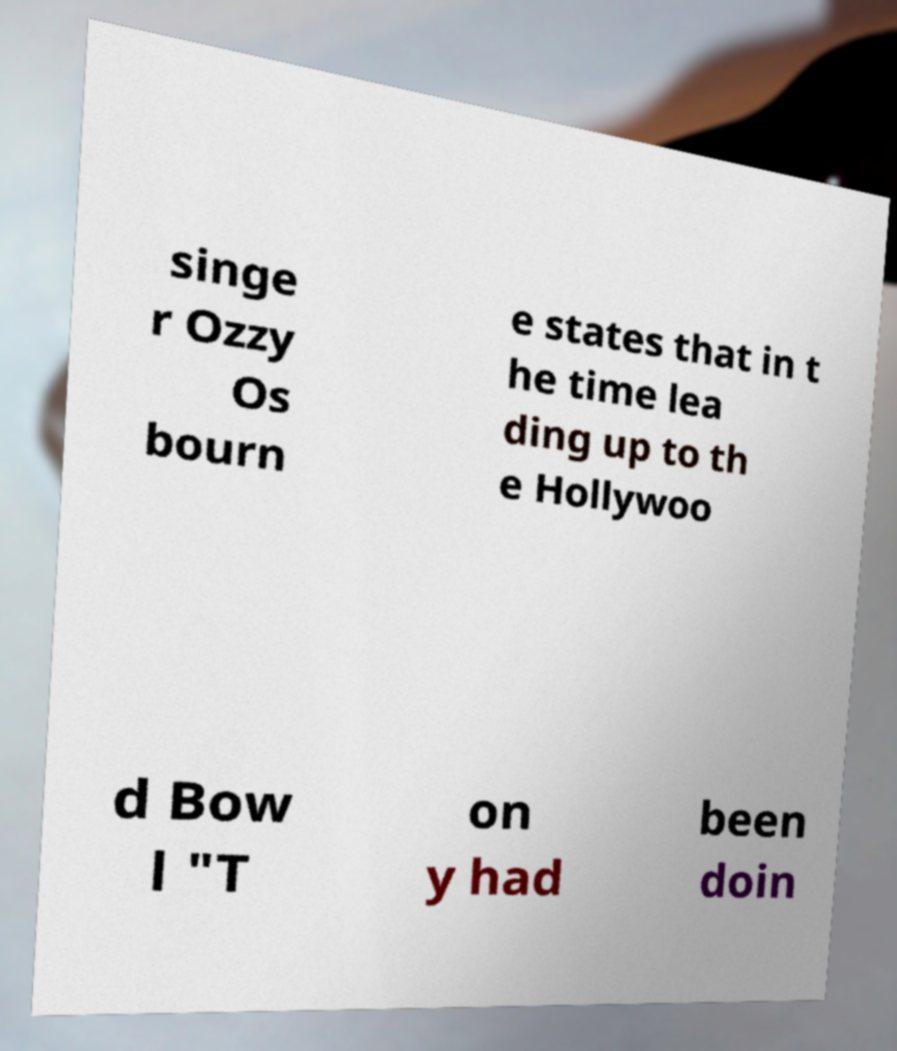There's text embedded in this image that I need extracted. Can you transcribe it verbatim? singe r Ozzy Os bourn e states that in t he time lea ding up to th e Hollywoo d Bow l "T on y had been doin 